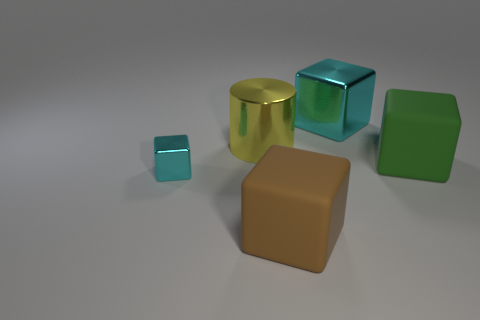The other thing that is the same color as the tiny object is what shape? The object sharing the same color as the tiny cube is a larger cube. Both exhibit the characteristics of a cube, having six faces, twelve edges, and are rendered in the same shade of turquoise. 